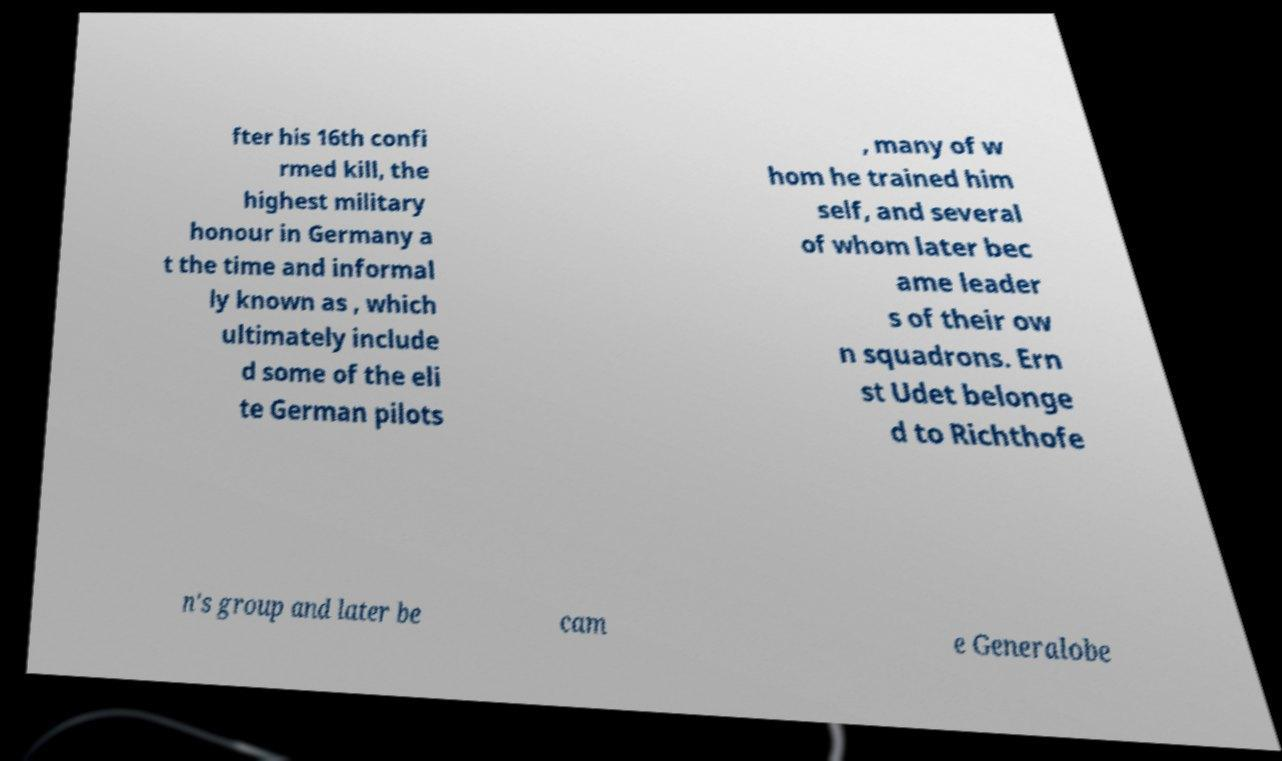I need the written content from this picture converted into text. Can you do that? fter his 16th confi rmed kill, the highest military honour in Germany a t the time and informal ly known as , which ultimately include d some of the eli te German pilots , many of w hom he trained him self, and several of whom later bec ame leader s of their ow n squadrons. Ern st Udet belonge d to Richthofe n's group and later be cam e Generalobe 